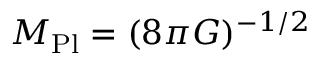Convert formula to latex. <formula><loc_0><loc_0><loc_500><loc_500>M _ { P l } = ( 8 \pi G ) ^ { - 1 / 2 }</formula> 